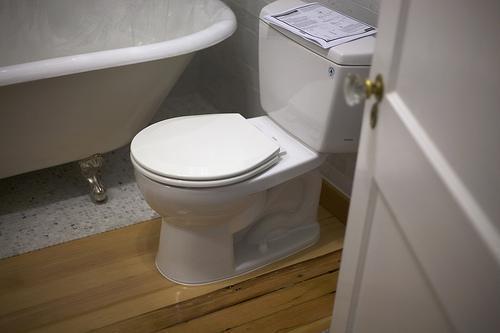How many kinds of flooring are there?
Give a very brief answer. 1. 